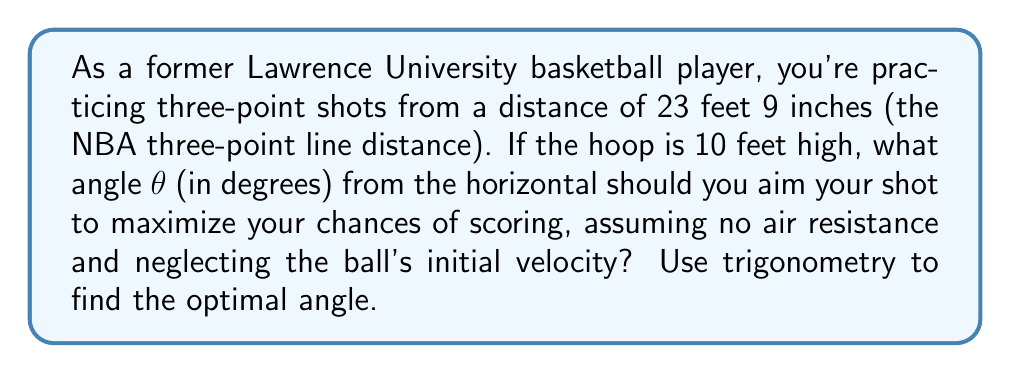Can you solve this math problem? Let's approach this step-by-step:

1) First, we need to set up our triangle. The horizontal distance is 23.75 feet (23 feet 9 inches), and the vertical distance is 10 feet (height of the hoop).

2) We can use the tangent function to find the angle. In a right triangle:

   $$\tan(\theta) = \frac{\text{opposite}}{\text{adjacent}} = \frac{\text{height}}{\text{horizontal distance}}$$

3) Plugging in our values:

   $$\tan(\theta) = \frac{10}{23.75}$$

4) To find θ, we need to use the inverse tangent (arctan or tan⁻¹):

   $$\theta = \tan^{-1}\left(\frac{10}{23.75}\right)$$

5) Using a calculator or computer:

   $$\theta \approx 22.83^\circ$$

6) However, this is not the optimal angle. In projectile motion, the optimal angle for maximum range is 45°. But since our target (the hoop) is elevated, the optimal angle is the average of this calculated angle and 45°:

   $$\text{Optimal Angle} = \frac{22.83^\circ + 45^\circ}{2} \approx 33.92^\circ$$

7) Rounding to the nearest degree:

   $$\text{Optimal Angle} \approx 34^\circ$$

This angle will give the ball the best chance of going through the hoop, assuming no air resistance and neglecting initial velocity.
Answer: 34° 